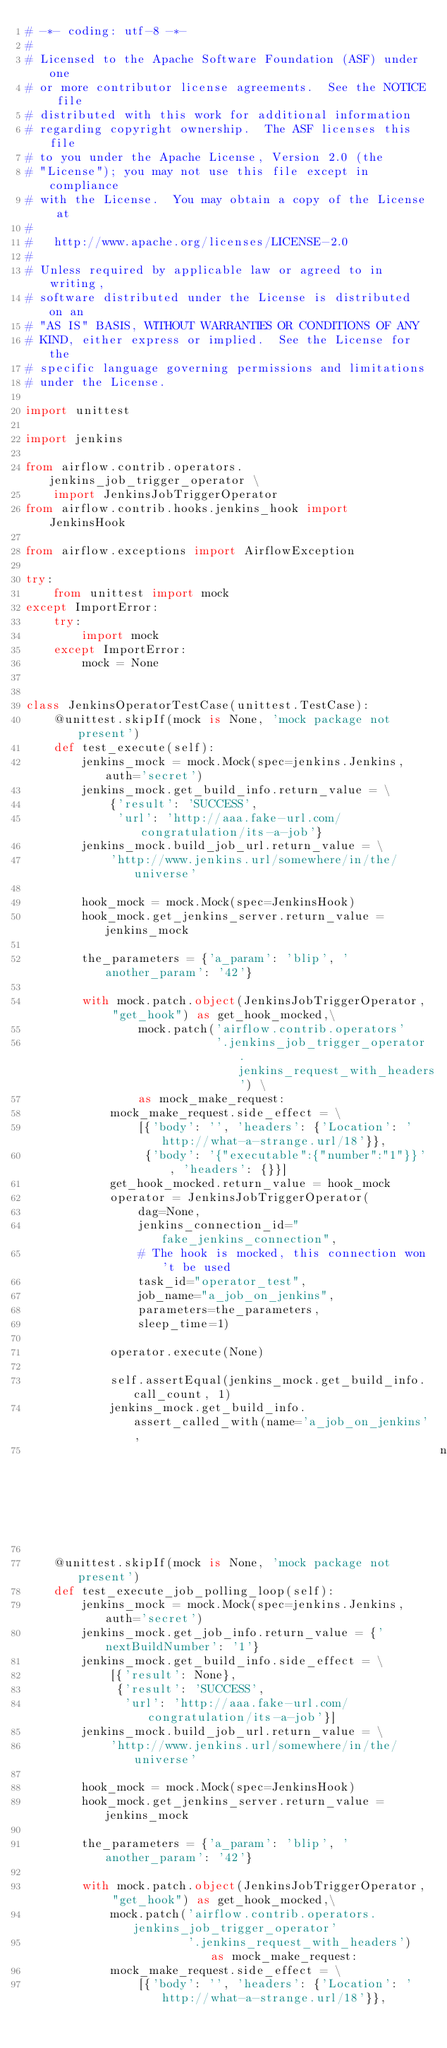Convert code to text. <code><loc_0><loc_0><loc_500><loc_500><_Python_># -*- coding: utf-8 -*-
#
# Licensed to the Apache Software Foundation (ASF) under one
# or more contributor license agreements.  See the NOTICE file
# distributed with this work for additional information
# regarding copyright ownership.  The ASF licenses this file
# to you under the Apache License, Version 2.0 (the
# "License"); you may not use this file except in compliance
# with the License.  You may obtain a copy of the License at
#
#   http://www.apache.org/licenses/LICENSE-2.0
#
# Unless required by applicable law or agreed to in writing,
# software distributed under the License is distributed on an
# "AS IS" BASIS, WITHOUT WARRANTIES OR CONDITIONS OF ANY
# KIND, either express or implied.  See the License for the
# specific language governing permissions and limitations
# under the License.

import unittest

import jenkins

from airflow.contrib.operators.jenkins_job_trigger_operator \
    import JenkinsJobTriggerOperator
from airflow.contrib.hooks.jenkins_hook import JenkinsHook

from airflow.exceptions import AirflowException

try:
    from unittest import mock
except ImportError:
    try:
        import mock
    except ImportError:
        mock = None


class JenkinsOperatorTestCase(unittest.TestCase):
    @unittest.skipIf(mock is None, 'mock package not present')
    def test_execute(self):
        jenkins_mock = mock.Mock(spec=jenkins.Jenkins, auth='secret')
        jenkins_mock.get_build_info.return_value = \
            {'result': 'SUCCESS',
             'url': 'http://aaa.fake-url.com/congratulation/its-a-job'}
        jenkins_mock.build_job_url.return_value = \
            'http://www.jenkins.url/somewhere/in/the/universe'

        hook_mock = mock.Mock(spec=JenkinsHook)
        hook_mock.get_jenkins_server.return_value = jenkins_mock

        the_parameters = {'a_param': 'blip', 'another_param': '42'}

        with mock.patch.object(JenkinsJobTriggerOperator, "get_hook") as get_hook_mocked,\
                mock.patch('airflow.contrib.operators'
                           '.jenkins_job_trigger_operator.jenkins_request_with_headers') \
                as mock_make_request:
            mock_make_request.side_effect = \
                [{'body': '', 'headers': {'Location': 'http://what-a-strange.url/18'}},
                 {'body': '{"executable":{"number":"1"}}', 'headers': {}}]
            get_hook_mocked.return_value = hook_mock
            operator = JenkinsJobTriggerOperator(
                dag=None,
                jenkins_connection_id="fake_jenkins_connection",
                # The hook is mocked, this connection won't be used
                task_id="operator_test",
                job_name="a_job_on_jenkins",
                parameters=the_parameters,
                sleep_time=1)

            operator.execute(None)

            self.assertEqual(jenkins_mock.get_build_info.call_count, 1)
            jenkins_mock.get_build_info.assert_called_with(name='a_job_on_jenkins',
                                                           number='1')

    @unittest.skipIf(mock is None, 'mock package not present')
    def test_execute_job_polling_loop(self):
        jenkins_mock = mock.Mock(spec=jenkins.Jenkins, auth='secret')
        jenkins_mock.get_job_info.return_value = {'nextBuildNumber': '1'}
        jenkins_mock.get_build_info.side_effect = \
            [{'result': None},
             {'result': 'SUCCESS',
              'url': 'http://aaa.fake-url.com/congratulation/its-a-job'}]
        jenkins_mock.build_job_url.return_value = \
            'http://www.jenkins.url/somewhere/in/the/universe'

        hook_mock = mock.Mock(spec=JenkinsHook)
        hook_mock.get_jenkins_server.return_value = jenkins_mock

        the_parameters = {'a_param': 'blip', 'another_param': '42'}

        with mock.patch.object(JenkinsJobTriggerOperator, "get_hook") as get_hook_mocked,\
            mock.patch('airflow.contrib.operators.jenkins_job_trigger_operator'
                       '.jenkins_request_with_headers') as mock_make_request:
            mock_make_request.side_effect = \
                [{'body': '', 'headers': {'Location': 'http://what-a-strange.url/18'}},</code> 